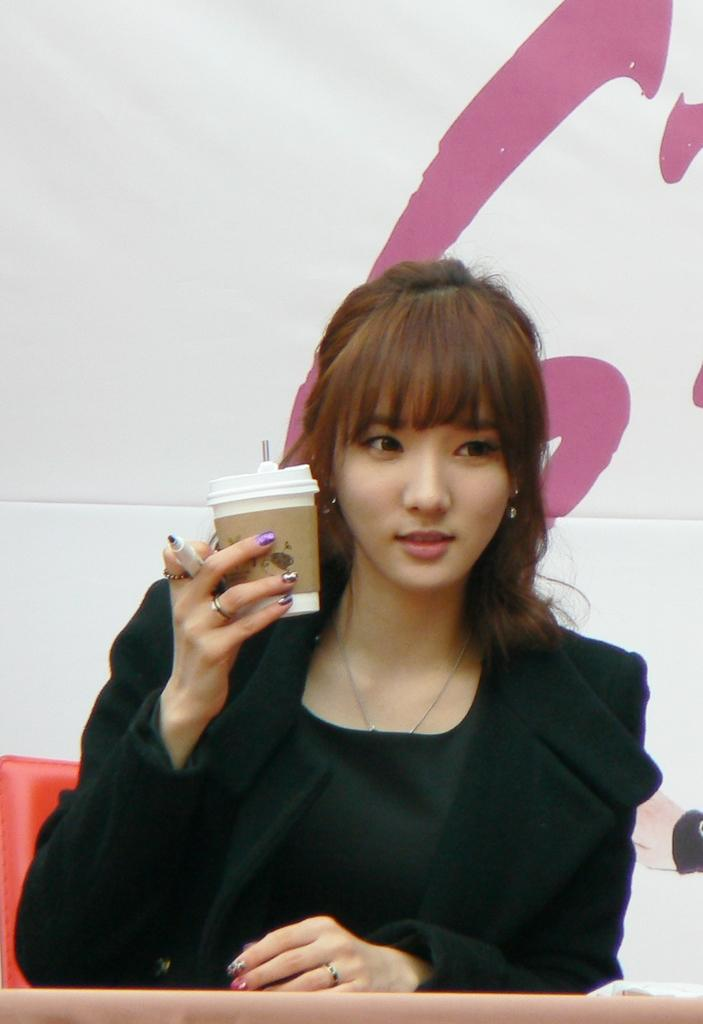Who is the main subject in the image? There is a girl in the image. What is the girl wearing? The girl is wearing a black dress. What is the girl holding in her hand? The girl is holding a marker pen and a glass. What can be seen in the background of the image? There is a banner in the background of the image. What is the girl's fear in the image? There is no indication of fear in the image; the girl is holding a marker pen and a glass. Is the girl celebrating her birthday in the image? There is no information about a birthday in the image; it only shows the girl holding a marker pen and a glass, along with a banner in the background. 